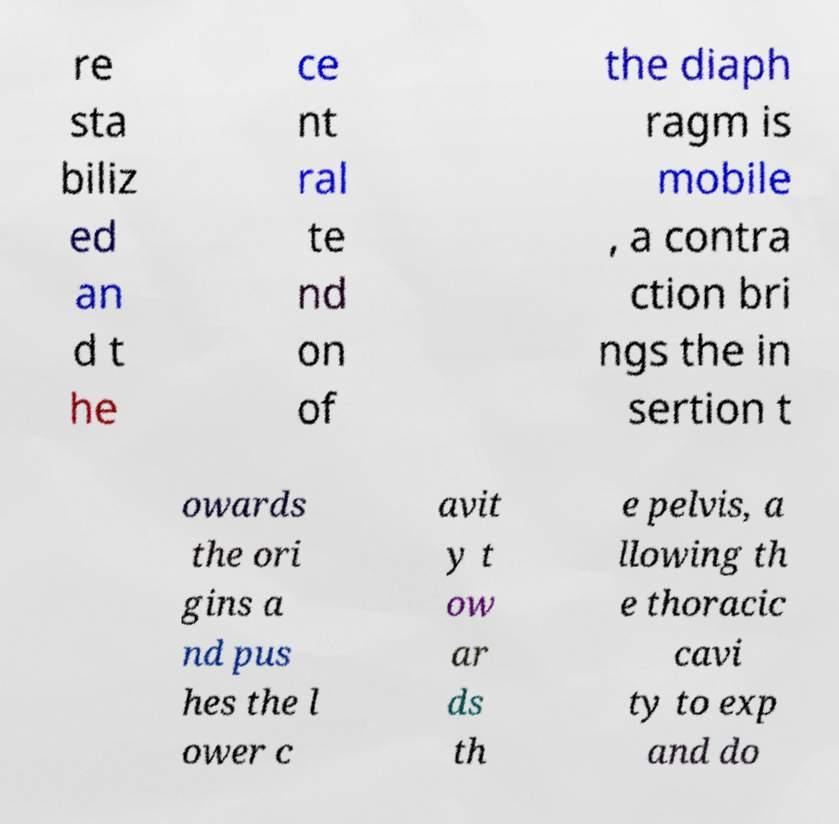Can you read and provide the text displayed in the image?This photo seems to have some interesting text. Can you extract and type it out for me? re sta biliz ed an d t he ce nt ral te nd on of the diaph ragm is mobile , a contra ction bri ngs the in sertion t owards the ori gins a nd pus hes the l ower c avit y t ow ar ds th e pelvis, a llowing th e thoracic cavi ty to exp and do 